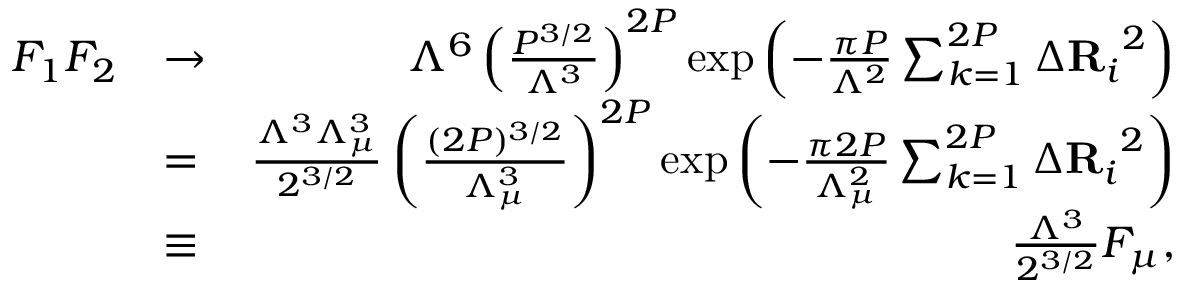Convert formula to latex. <formula><loc_0><loc_0><loc_500><loc_500>\begin{array} { r l r } { F _ { 1 } F _ { 2 } } & { \to } & { \Lambda ^ { 6 } \left ( \frac { P ^ { 3 / 2 } } { \Lambda ^ { 3 } } \right ) ^ { 2 P } \exp \left ( - \frac { \pi P } { \Lambda ^ { 2 } } \sum _ { k = 1 } ^ { 2 P } { \Delta R _ { i } } ^ { 2 } \right ) } \\ & { = } & { \frac { \Lambda ^ { 3 } \Lambda _ { \mu } ^ { 3 } } { 2 ^ { 3 / 2 } } \left ( \frac { ( 2 P ) ^ { 3 / 2 } } { \Lambda _ { \mu } ^ { 3 } } \right ) ^ { 2 P } \exp \left ( - \frac { \pi 2 P } { \Lambda _ { \mu } ^ { 2 } } \sum _ { k = 1 } ^ { 2 P } { \Delta R _ { i } } ^ { 2 } \right ) } \\ & { \equiv } & { \frac { \Lambda ^ { 3 } } { 2 ^ { 3 / 2 } } F _ { \mu } , } \end{array}</formula> 